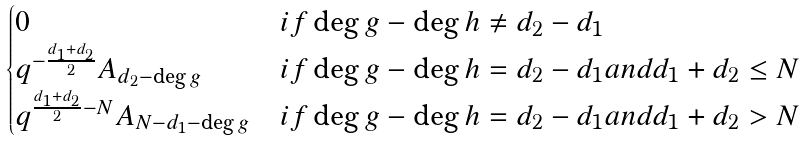Convert formula to latex. <formula><loc_0><loc_0><loc_500><loc_500>\begin{cases} 0 & i f \deg g - \deg h \neq d _ { 2 } - d _ { 1 } \\ q ^ { - \frac { d _ { 1 } + d _ { 2 } } { 2 } } A _ { d _ { 2 } - \deg g } & i f \deg g - \deg h = d _ { 2 } - d _ { 1 } a n d d _ { 1 } + d _ { 2 } \leq N \\ q ^ { \frac { d _ { 1 } + d _ { 2 } } { 2 } - N } A _ { N - d _ { 1 } - \deg g } & i f \deg g - \deg h = d _ { 2 } - d _ { 1 } a n d d _ { 1 } + d _ { 2 } > N \end{cases}</formula> 